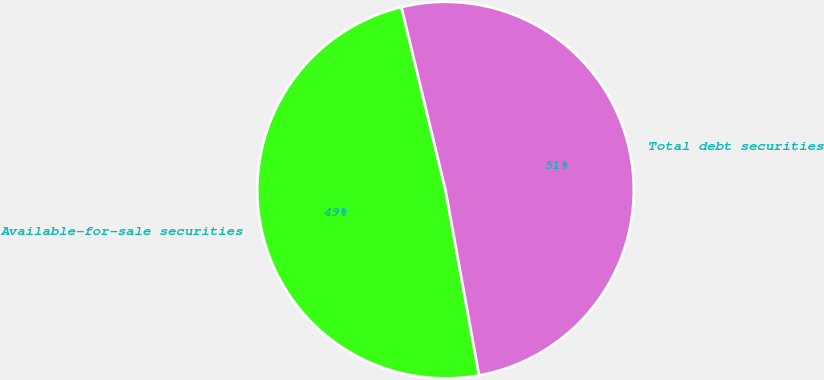Convert chart to OTSL. <chart><loc_0><loc_0><loc_500><loc_500><pie_chart><fcel>Available-for-sale securities<fcel>Total debt securities<nl><fcel>49.09%<fcel>50.91%<nl></chart> 